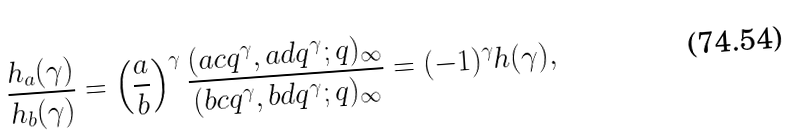<formula> <loc_0><loc_0><loc_500><loc_500>\frac { h _ { a } ( \gamma ) } { h _ { b } ( \gamma ) } = \left ( \frac { a } { b } \right ) ^ { \gamma } \frac { ( a c q ^ { \gamma } , a d q ^ { \gamma } ; q ) _ { \infty } } { ( b c q ^ { \gamma } , b d q ^ { \gamma } ; q ) _ { \infty } } = ( - 1 ) ^ { \gamma } h ( \gamma ) ,</formula> 